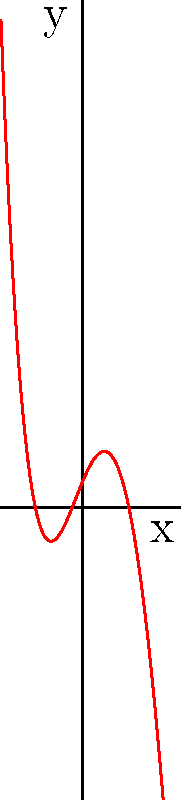As a point guard constantly pushing your skills, analyze this polynomial graph representing your team's performance over time. Identify the number and types of critical points in the graph. How many local maxima, local minima, and inflection points does this function have? To identify the critical points, we need to analyze the behavior of the function:

1. Local maxima and minima:
   - Local maxima occur where the function changes from increasing to decreasing.
   - Local minima occur where the function changes from decreasing to increasing.
   - We can see one local maximum and one local minimum in the graph.

2. Inflection points:
   - Inflection points occur where the concavity of the function changes.
   - We can observe two inflection points in the graph.

3. Counting the critical points:
   - Local maxima: 1 (near $x=-1$)
   - Local minima: 1 (near $x=2$)
   - Inflection points: 2 (one between the local maximum and minimum, and another to the right of the local minimum)

Therefore, the function has:
- 1 local maximum
- 1 local minimum
- 2 inflection points
Answer: 1 local maximum, 1 local minimum, 2 inflection points 